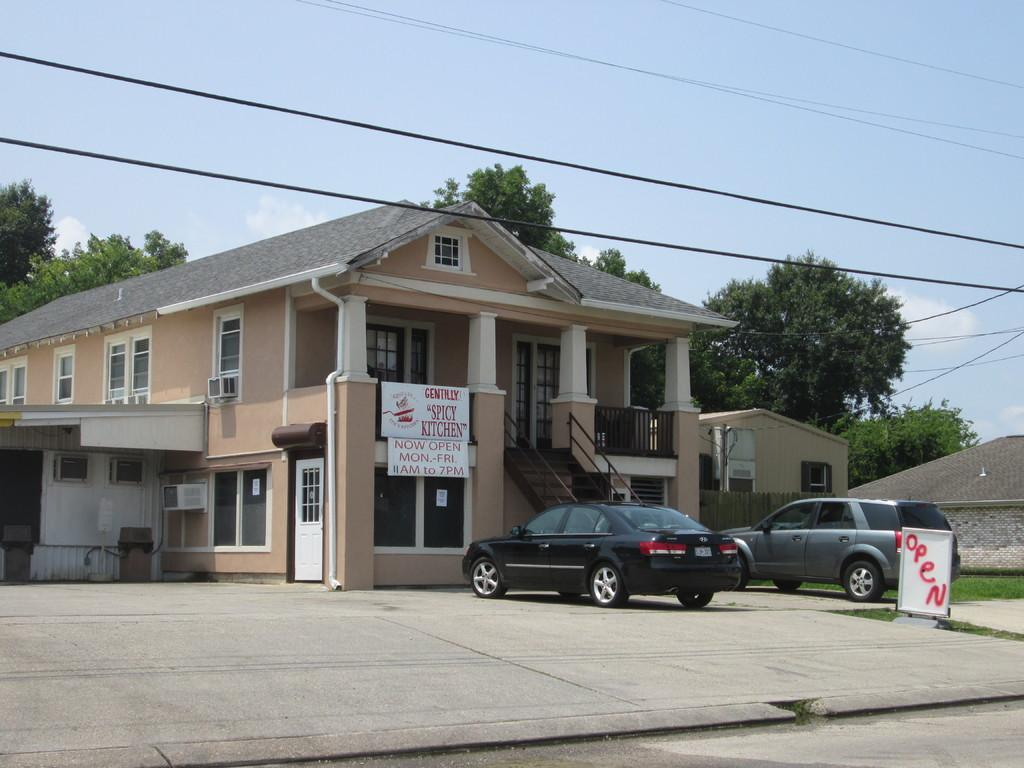What type of vehicles can be seen in the image? There are cars in the image. What structures are present in the image? There are buildings in the image. What objects are featured on the boards in the image? The facts do not specify what is on the boards, so we cannot answer this question definitively. What type of vegetation is visible in the background of the image? There are trees in the background of the image. What type of infrastructure is visible at the top of the image? There are cables visible at the top of the image. What is visible in the sky at the top of the image? The sky is visible at the top of the image. How many sisters are performing on the stage in the image? There is no stage or sisters present in the image. What type of twist can be seen in the image? There is no twist visible in the image. 